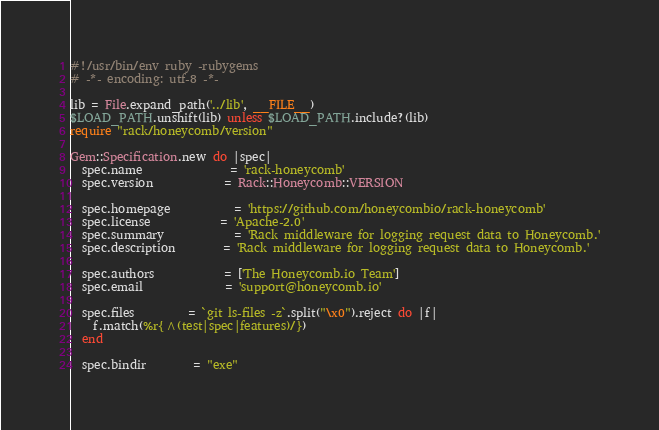<code> <loc_0><loc_0><loc_500><loc_500><_Ruby_>#!/usr/bin/env ruby -rubygems
# -*- encoding: utf-8 -*-

lib = File.expand_path('../lib', __FILE__)
$LOAD_PATH.unshift(lib) unless $LOAD_PATH.include?(lib)
require "rack/honeycomb/version"

Gem::Specification.new do |spec|
  spec.name               = 'rack-honeycomb'
  spec.version            = Rack::Honeycomb::VERSION

  spec.homepage           = 'https://github.com/honeycombio/rack-honeycomb'
  spec.license            = 'Apache-2.0'
  spec.summary            = 'Rack middleware for logging request data to Honeycomb.'
  spec.description        = 'Rack middleware for logging request data to Honeycomb.'

  spec.authors            = ['The Honeycomb.io Team']
  spec.email              = 'support@honeycomb.io'

  spec.files         = `git ls-files -z`.split("\x0").reject do |f|
    f.match(%r{^(test|spec|features)/})
  end

  spec.bindir        = "exe"</code> 